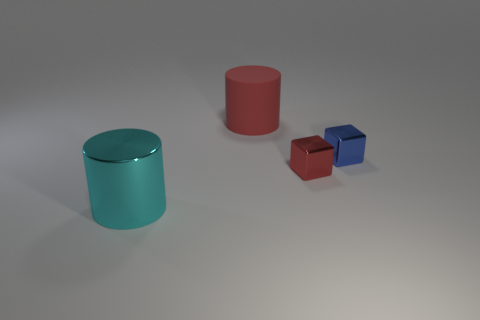How would the lighting in the room affect the appearance of these objects? The objects' glossy surfaces would reflect light strongly, so changes in the room's lighting could create interesting highlights and shadows, enhancing their visual appeal. Direct light might produce sharp glare, while diffuse light would soften the appearance of the objects and their reflections on the surface they rest on. 